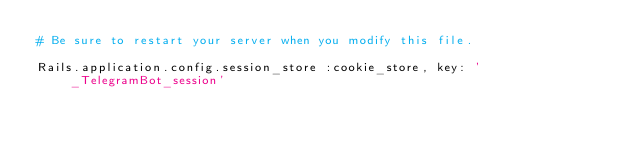<code> <loc_0><loc_0><loc_500><loc_500><_Ruby_># Be sure to restart your server when you modify this file.

Rails.application.config.session_store :cookie_store, key: '_TelegramBot_session'
</code> 